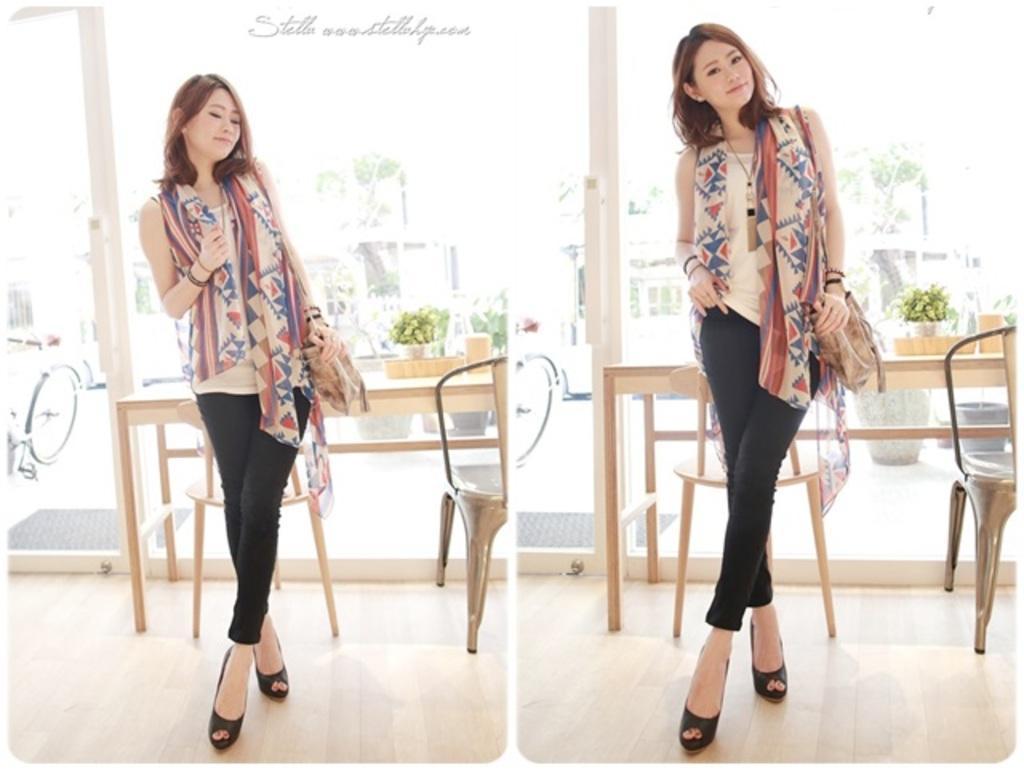In one or two sentences, can you explain what this image depicts? This image looks like it is edited and made has a collage. In this image, we can see a woman wearing a scarf and a bag. Behind her, there is a table along with chairs. In the background, there is glass window. 